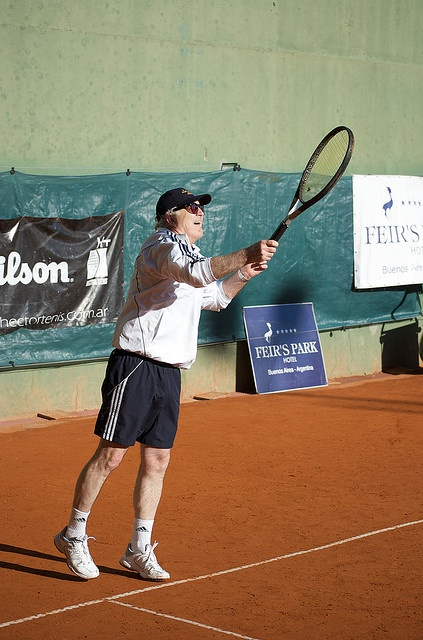Describe the objects in this image and their specific colors. I can see people in darkgray, black, white, gray, and maroon tones and tennis racket in darkgray, black, tan, and gray tones in this image. 